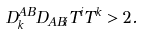Convert formula to latex. <formula><loc_0><loc_0><loc_500><loc_500>D ^ { A B } _ { k } D _ { A B i } T ^ { i } T ^ { k } > 2 .</formula> 